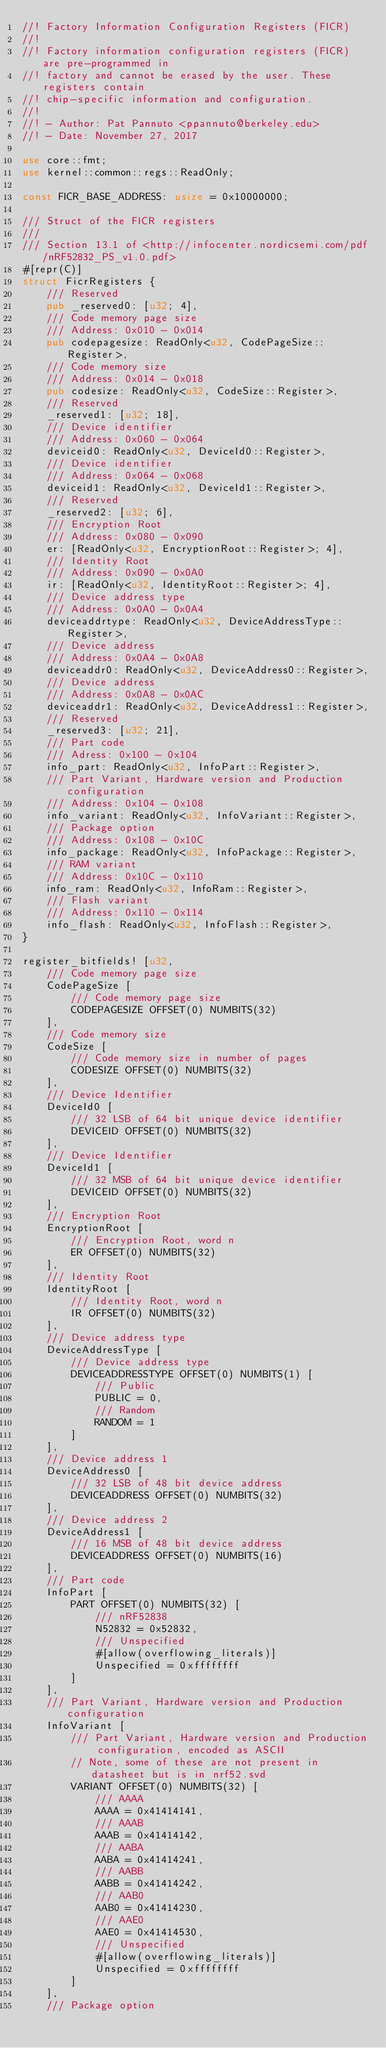Convert code to text. <code><loc_0><loc_0><loc_500><loc_500><_Rust_>//! Factory Information Configuration Registers (FICR)
//!
//! Factory information configuration registers (FICR) are pre-programmed in
//! factory and cannot be erased by the user. These registers contain
//! chip-specific information and configuration.
//!
//! - Author: Pat Pannuto <ppannuto@berkeley.edu>
//! - Date: November 27, 2017

use core::fmt;
use kernel::common::regs::ReadOnly;

const FICR_BASE_ADDRESS: usize = 0x10000000;

/// Struct of the FICR registers
///
/// Section 13.1 of <http://infocenter.nordicsemi.com/pdf/nRF52832_PS_v1.0.pdf>
#[repr(C)]
struct FicrRegisters {
    /// Reserved
    pub _reserved0: [u32; 4],
    /// Code memory page size
    /// Address: 0x010 - 0x014
    pub codepagesize: ReadOnly<u32, CodePageSize::Register>,
    /// Code memory size
    /// Address: 0x014 - 0x018
    pub codesize: ReadOnly<u32, CodeSize::Register>,
    /// Reserved
    _reserved1: [u32; 18],
    /// Device identifier
    /// Address: 0x060 - 0x064
    deviceid0: ReadOnly<u32, DeviceId0::Register>,
    /// Device identifier
    /// Address: 0x064 - 0x068
    deviceid1: ReadOnly<u32, DeviceId1::Register>,
    /// Reserved
    _reserved2: [u32; 6],
    /// Encryption Root
    /// Address: 0x080 - 0x090
    er: [ReadOnly<u32, EncryptionRoot::Register>; 4],
    /// Identity Root
    /// Address: 0x090 - 0x0A0
    ir: [ReadOnly<u32, IdentityRoot::Register>; 4],
    /// Device address type
    /// Address: 0x0A0 - 0x0A4
    deviceaddrtype: ReadOnly<u32, DeviceAddressType::Register>,
    /// Device address
    /// Address: 0x0A4 - 0x0A8
    deviceaddr0: ReadOnly<u32, DeviceAddress0::Register>,
    /// Device address
    /// Address: 0x0A8 - 0x0AC
    deviceaddr1: ReadOnly<u32, DeviceAddress1::Register>,
    /// Reserved
    _reserved3: [u32; 21],
    /// Part code
    /// Adress: 0x100 - 0x104
    info_part: ReadOnly<u32, InfoPart::Register>,
    /// Part Variant, Hardware version and Production configuration
    /// Address: 0x104 - 0x108
    info_variant: ReadOnly<u32, InfoVariant::Register>,
    /// Package option
    /// Address: 0x108 - 0x10C
    info_package: ReadOnly<u32, InfoPackage::Register>,
    /// RAM variant
    /// Address: 0x10C - 0x110
    info_ram: ReadOnly<u32, InfoRam::Register>,
    /// Flash variant
    /// Address: 0x110 - 0x114
    info_flash: ReadOnly<u32, InfoFlash::Register>,
}

register_bitfields! [u32,
    /// Code memory page size
    CodePageSize [
        /// Code memory page size
        CODEPAGESIZE OFFSET(0) NUMBITS(32)
    ],
    /// Code memory size
    CodeSize [
        /// Code memory size in number of pages
        CODESIZE OFFSET(0) NUMBITS(32)
    ],
    /// Device Identifier
    DeviceId0 [
        /// 32 LSB of 64 bit unique device identifier
        DEVICEID OFFSET(0) NUMBITS(32)
    ],
    /// Device Identifier
    DeviceId1 [
        /// 32 MSB of 64 bit unique device identifier
        DEVICEID OFFSET(0) NUMBITS(32)
    ],
    /// Encryption Root
    EncryptionRoot [
        /// Encryption Root, word n
        ER OFFSET(0) NUMBITS(32)
    ],
    /// Identity Root
    IdentityRoot [
        /// Identity Root, word n
        IR OFFSET(0) NUMBITS(32)
    ],
    /// Device address type
    DeviceAddressType [
        /// Device address type
        DEVICEADDRESSTYPE OFFSET(0) NUMBITS(1) [
            /// Public
            PUBLIC = 0,
            /// Random
            RANDOM = 1
        ]
    ],
    /// Device address 1
    DeviceAddress0 [
        /// 32 LSB of 48 bit device address
        DEVICEADDRESS OFFSET(0) NUMBITS(32)
    ],
    /// Device address 2
    DeviceAddress1 [
        /// 16 MSB of 48 bit device address
        DEVICEADDRESS OFFSET(0) NUMBITS(16)
    ],
    /// Part code
    InfoPart [
        PART OFFSET(0) NUMBITS(32) [
            /// nRF52838
            N52832 = 0x52832,
            /// Unspecified
            #[allow(overflowing_literals)]
            Unspecified = 0xffffffff
        ]
    ],
    /// Part Variant, Hardware version and Production configuration
    InfoVariant [
        /// Part Variant, Hardware version and Production configuration, encoded as ASCII
        // Note, some of these are not present in datasheet but is in nrf52.svd
        VARIANT OFFSET(0) NUMBITS(32) [
            /// AAAA
            AAAA = 0x41414141,
            /// AAAB
            AAAB = 0x41414142,
            /// AABA
            AABA = 0x41414241,
            /// AABB
            AABB = 0x41414242,
            /// AAB0
            AAB0 = 0x41414230,
            /// AAE0
            AAE0 = 0x41414530,
            /// Unspecified
            #[allow(overflowing_literals)]
            Unspecified = 0xffffffff
        ]
    ],
    /// Package option</code> 